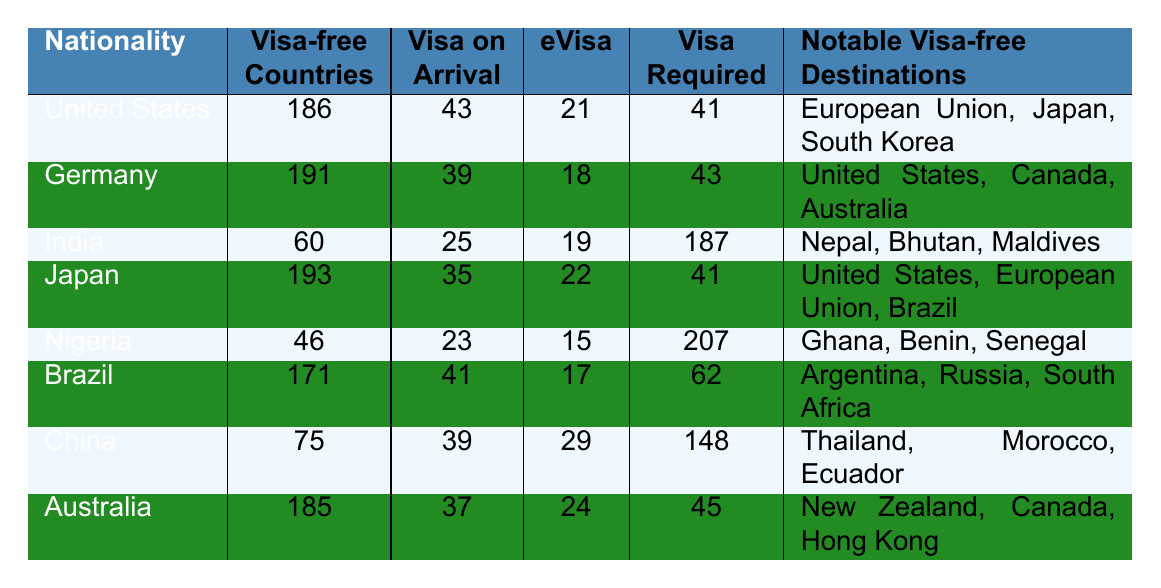What is the nationality with the most visa-free countries? By examining the "Visa-free Countries" column, we see that Germany has the highest count with 191 visa-free countries.
Answer: Germany How many visa-free countries does Brazil have? Looking at Brazil's row in the "Visa-free Countries" column, Brazil has 171 visa-free countries.
Answer: 171 Which nationality has the highest number of visa requirements? Checking the "Visa Required" column, Nigeria has the highest number with 207 visa requirements.
Answer: Nigeria How many countries offer a visa on arrival for Indian nationals? By referring to the "Visa on Arrival" column next to India, it shows that there are 25 countries that offer this option.
Answer: 25 What is the total number of visa-free countries for the United States and Japan combined? The United States has 186 visa-free countries, and Japan has 193. Adding these together gives us 186 + 193 = 379.
Answer: 379 Are there more eVisa options for China or Brazil? China has 29 eVisa options, while Brazil has 17. Since 29 is greater than 17, it means China has more eVisa options than Brazil.
Answer: Yes What percentage of countries does Nigeria require a visa for, based on the total number of countries provided in the table? Nigeria has 207 visa requirements out of a total of 195 countries listed (the sum of visa-free, visa on arrival, eVisa, and visa required). To find the percentage: (207 / 195) * 100 ≈ 106.15%, indicating all countries plus some require a visa for Nigeria.
Answer: Approximately 106.15% If a traveler has a United States passport, what notable visa-free destination can they visit? The notable visa-free destinations for U.S. passport holders listed in the table include the European Union, Japan, and South Korea. Since any of these can be correct, one example is Japan.
Answer: Japan Which nationality requires the least visas? Comparing the "Visa Required" column, India requires the least with 187 visas, while all others have higher requirements. Therefore, the nationality with the least insurance is India.
Answer: India How many more visa-free countries does Japan have than Nigeria? Japan has 193 visa-free countries, while Nigeria has 46. To find the difference, subtract: 193 - 46 = 147.
Answer: 147 